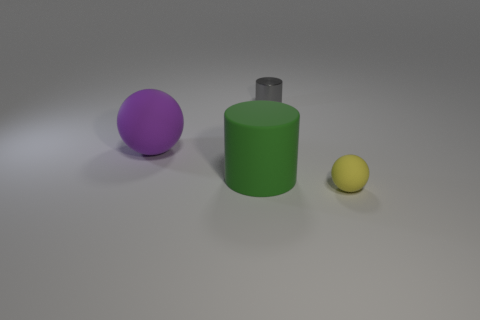Add 3 yellow rubber balls. How many objects exist? 7 Add 2 gray objects. How many gray objects are left? 3 Add 3 big things. How many big things exist? 5 Subtract 1 purple balls. How many objects are left? 3 Subtract all yellow rubber spheres. Subtract all big purple balls. How many objects are left? 2 